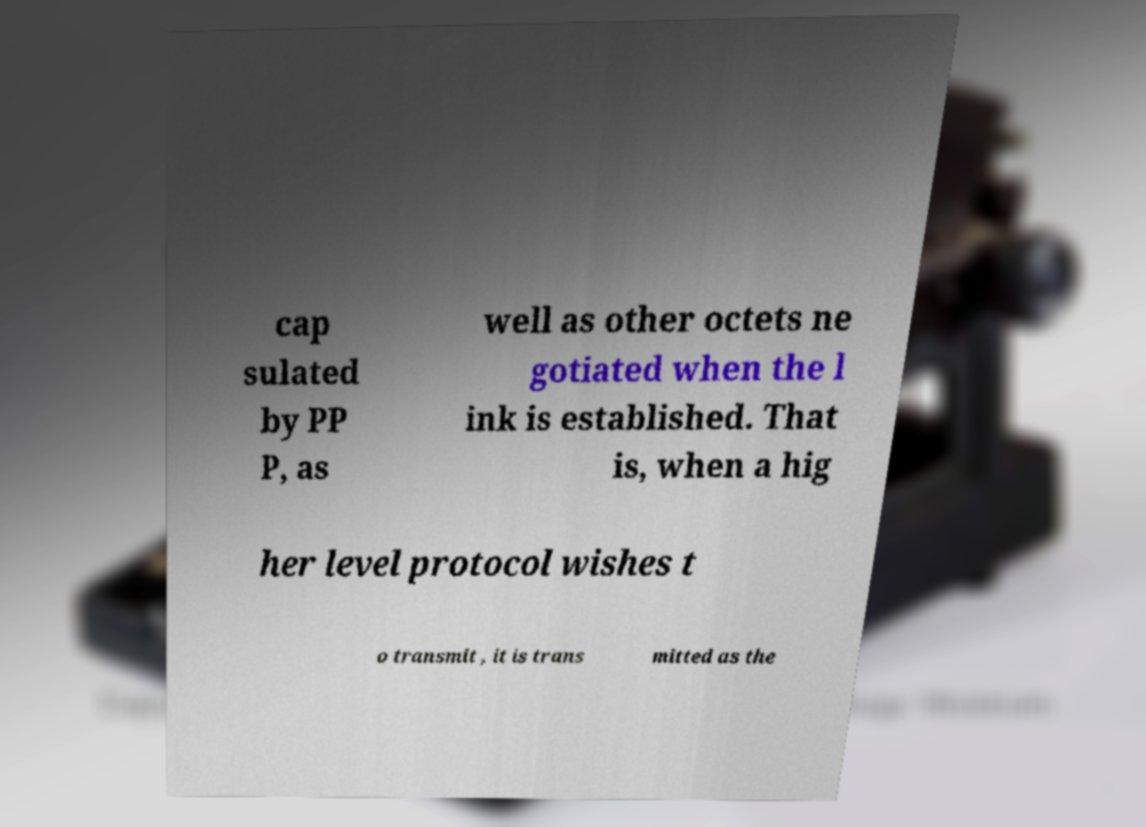I need the written content from this picture converted into text. Can you do that? cap sulated by PP P, as well as other octets ne gotiated when the l ink is established. That is, when a hig her level protocol wishes t o transmit , it is trans mitted as the 